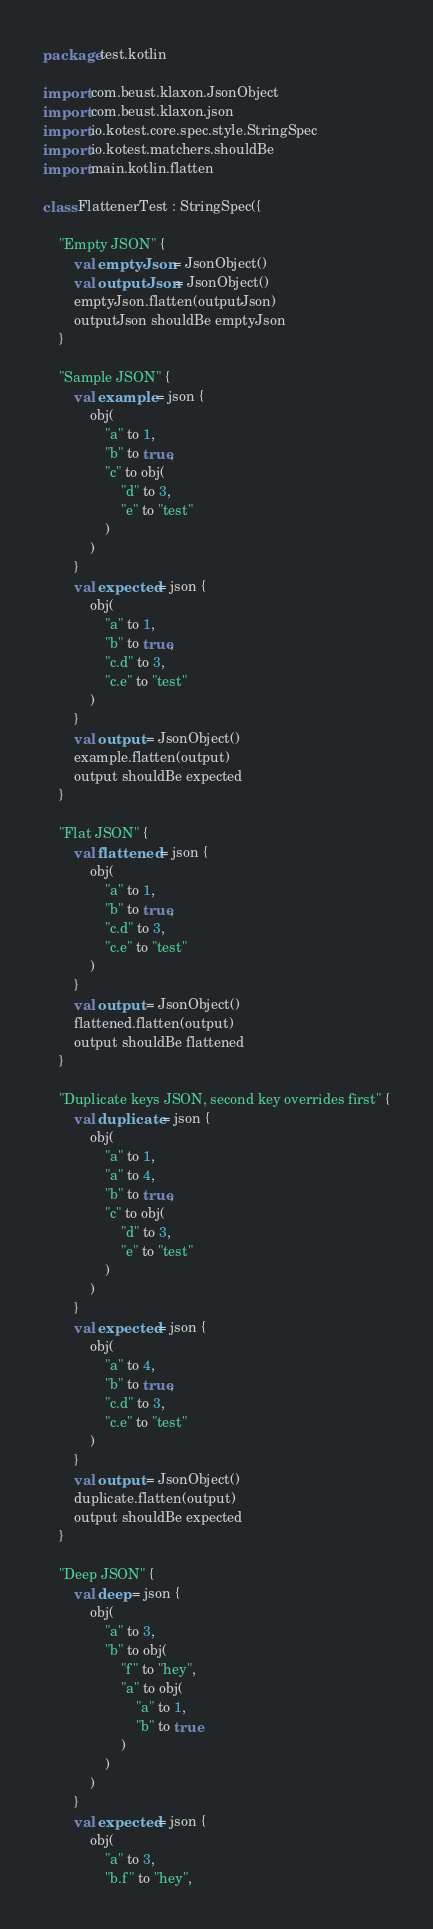<code> <loc_0><loc_0><loc_500><loc_500><_Kotlin_>package test.kotlin

import com.beust.klaxon.JsonObject
import com.beust.klaxon.json
import io.kotest.core.spec.style.StringSpec
import io.kotest.matchers.shouldBe
import main.kotlin.flatten

class FlattenerTest : StringSpec({

    "Empty JSON" {
        val emptyJson = JsonObject()
        val outputJson = JsonObject()
        emptyJson.flatten(outputJson)
        outputJson shouldBe emptyJson
    }

    "Sample JSON" {
        val example = json {
            obj(
                "a" to 1,
                "b" to true,
                "c" to obj(
                    "d" to 3,
                    "e" to "test"
                )
            )
        }
        val expected = json {
            obj(
                "a" to 1,
                "b" to true,
                "c.d" to 3,
                "c.e" to "test"
            )
        }
        val output = JsonObject()
        example.flatten(output)
        output shouldBe expected
    }

    "Flat JSON" {
        val flattened = json {
            obj(
                "a" to 1,
                "b" to true,
                "c.d" to 3,
                "c.e" to "test"
            )
        }
        val output = JsonObject()
        flattened.flatten(output)
        output shouldBe flattened
    }

    "Duplicate keys JSON, second key overrides first" {
        val duplicate = json {
            obj(
                "a" to 1,
                "a" to 4,
                "b" to true,
                "c" to obj(
                    "d" to 3,
                    "e" to "test"
                )
            )
        }
        val expected = json {
            obj(
                "a" to 4,
                "b" to true,
                "c.d" to 3,
                "c.e" to "test"
            )
        }
        val output = JsonObject()
        duplicate.flatten(output)
        output shouldBe expected
    }

    "Deep JSON" {
        val deep = json {
            obj(
                "a" to 3,
                "b" to obj(
                    "f" to "hey",
                    "a" to obj(
                        "a" to 1,
                        "b" to true
                    )
                )
            )
        }
        val expected = json {
            obj(
                "a" to 3,
                "b.f" to "hey",</code> 